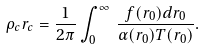<formula> <loc_0><loc_0><loc_500><loc_500>\rho _ { c } r _ { c } = \frac { 1 } { 2 \pi } \int ^ { \infty } _ { 0 } \, \frac { f ( r _ { 0 } ) d r _ { 0 } } { \alpha ( r _ { 0 } ) T ( r _ { 0 } ) } .</formula> 